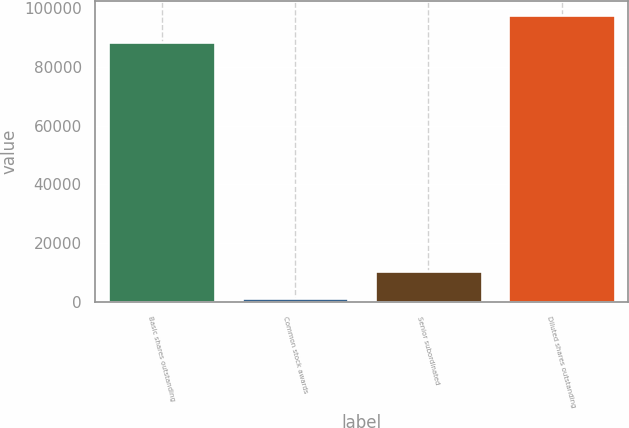Convert chart. <chart><loc_0><loc_0><loc_500><loc_500><bar_chart><fcel>Basic shares outstanding<fcel>Common stock awards<fcel>Senior subordinated<fcel>Diluted shares outstanding<nl><fcel>88390<fcel>1511<fcel>10682.8<fcel>97561.8<nl></chart> 